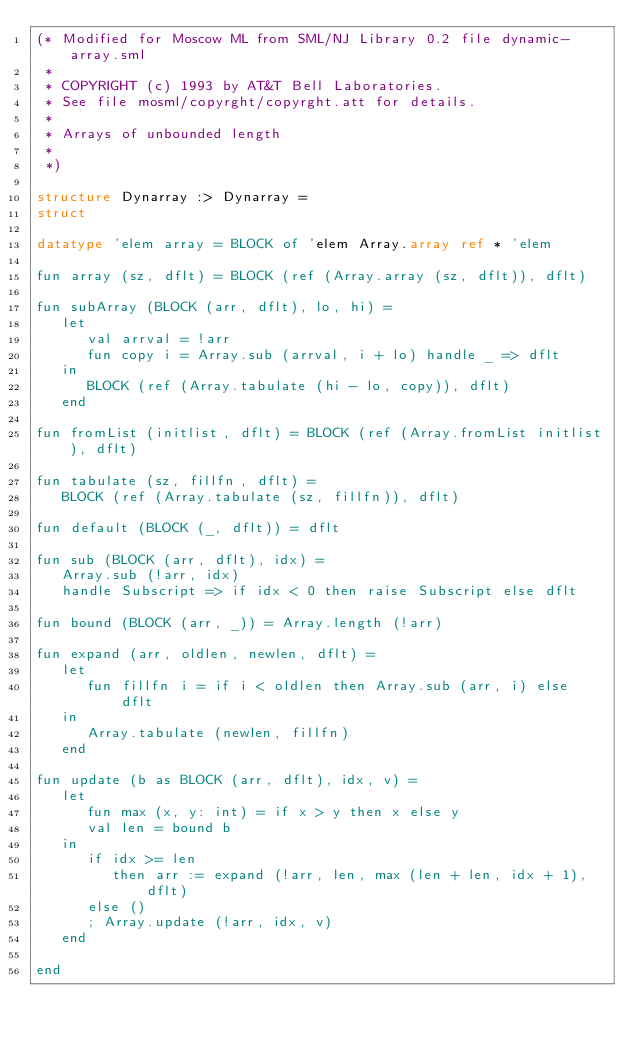Convert code to text. <code><loc_0><loc_0><loc_500><loc_500><_SML_>(* Modified for Moscow ML from SML/NJ Library 0.2 file dynamic-array.sml
 *
 * COPYRIGHT (c) 1993 by AT&T Bell Laboratories.
 * See file mosml/copyrght/copyrght.att for details.
 *
 * Arrays of unbounded length
 *
 *)

structure Dynarray :> Dynarray =
struct

datatype 'elem array = BLOCK of 'elem Array.array ref * 'elem

fun array (sz, dflt) = BLOCK (ref (Array.array (sz, dflt)), dflt)

fun subArray (BLOCK (arr, dflt), lo, hi) =
   let
      val arrval = !arr
      fun copy i = Array.sub (arrval, i + lo) handle _ => dflt
   in
      BLOCK (ref (Array.tabulate (hi - lo, copy)), dflt)
   end

fun fromList (initlist, dflt) = BLOCK (ref (Array.fromList initlist), dflt)

fun tabulate (sz, fillfn, dflt) =
   BLOCK (ref (Array.tabulate (sz, fillfn)), dflt)

fun default (BLOCK (_, dflt)) = dflt

fun sub (BLOCK (arr, dflt), idx) =
   Array.sub (!arr, idx)
   handle Subscript => if idx < 0 then raise Subscript else dflt

fun bound (BLOCK (arr, _)) = Array.length (!arr)

fun expand (arr, oldlen, newlen, dflt) =
   let
      fun fillfn i = if i < oldlen then Array.sub (arr, i) else dflt
   in
      Array.tabulate (newlen, fillfn)
   end

fun update (b as BLOCK (arr, dflt), idx, v) =
   let
      fun max (x, y: int) = if x > y then x else y
      val len = bound b
   in
      if idx >= len
         then arr := expand (!arr, len, max (len + len, idx + 1), dflt)
      else ()
      ; Array.update (!arr, idx, v)
   end

end
</code> 